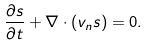<formula> <loc_0><loc_0><loc_500><loc_500>\frac { \partial s } { \partial t } + \nabla \cdot ( { v } _ { n } s ) = 0 .</formula> 